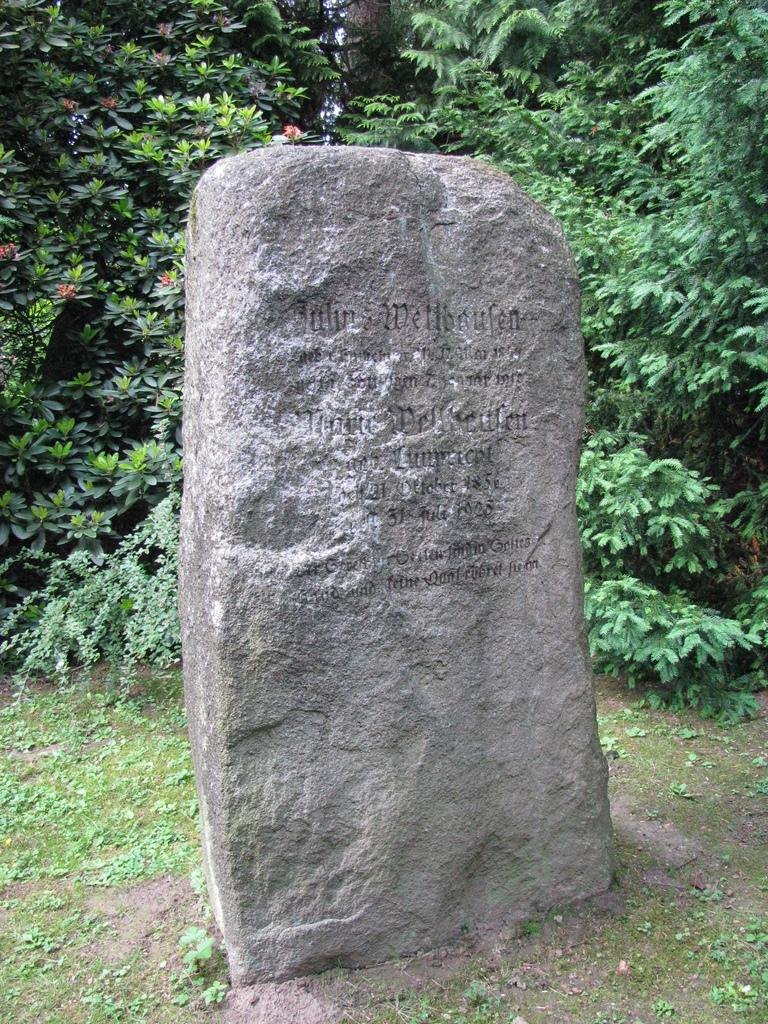What is the main object in the image? There is a headstone with text in the image. What type of vegetation can be seen in the image? There are trees in the image. What is the ground covered with in the image? There is grass in the image. What type of pencil can be seen in the image? There is no pencil present in the image. How many pies are visible in the image? There are no pies present in the image. 